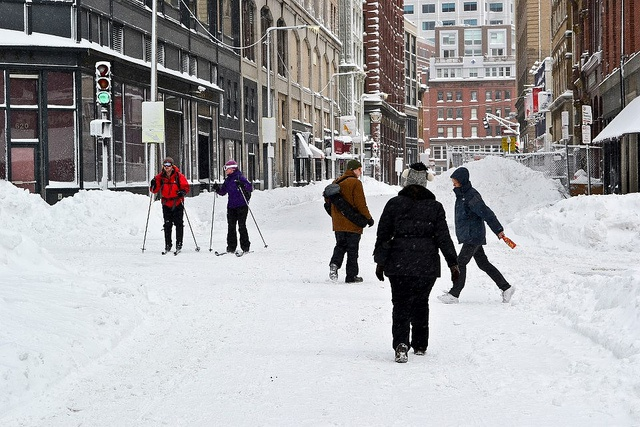Describe the objects in this image and their specific colors. I can see people in black, white, gray, and darkgray tones, people in black, lightgray, and darkgray tones, people in black, maroon, gray, and lightgray tones, people in black, navy, lightgray, and gray tones, and people in black, maroon, brown, and red tones in this image. 